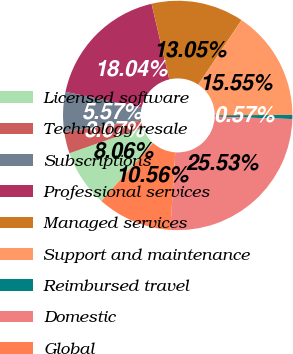<chart> <loc_0><loc_0><loc_500><loc_500><pie_chart><fcel>Licensed software<fcel>Technology resale<fcel>Subscriptions<fcel>Professional services<fcel>Managed services<fcel>Support and maintenance<fcel>Reimbursed travel<fcel>Domestic<fcel>Global<nl><fcel>8.06%<fcel>3.07%<fcel>5.57%<fcel>18.04%<fcel>13.05%<fcel>15.55%<fcel>0.57%<fcel>25.53%<fcel>10.56%<nl></chart> 